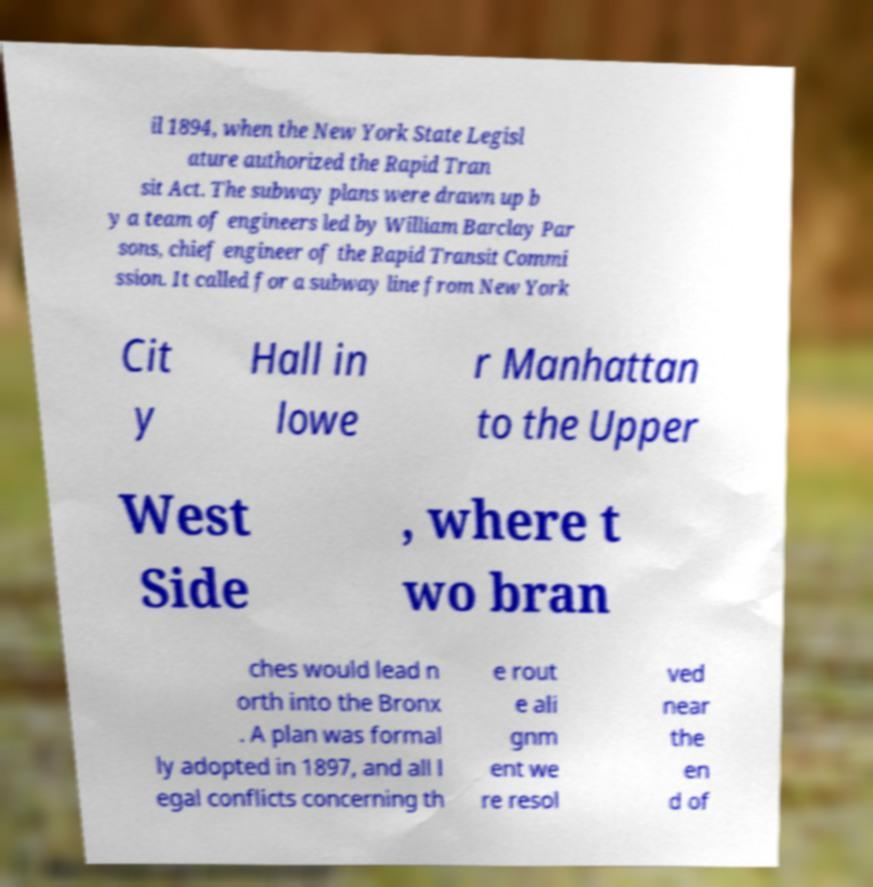Could you extract and type out the text from this image? il 1894, when the New York State Legisl ature authorized the Rapid Tran sit Act. The subway plans were drawn up b y a team of engineers led by William Barclay Par sons, chief engineer of the Rapid Transit Commi ssion. It called for a subway line from New York Cit y Hall in lowe r Manhattan to the Upper West Side , where t wo bran ches would lead n orth into the Bronx . A plan was formal ly adopted in 1897, and all l egal conflicts concerning th e rout e ali gnm ent we re resol ved near the en d of 